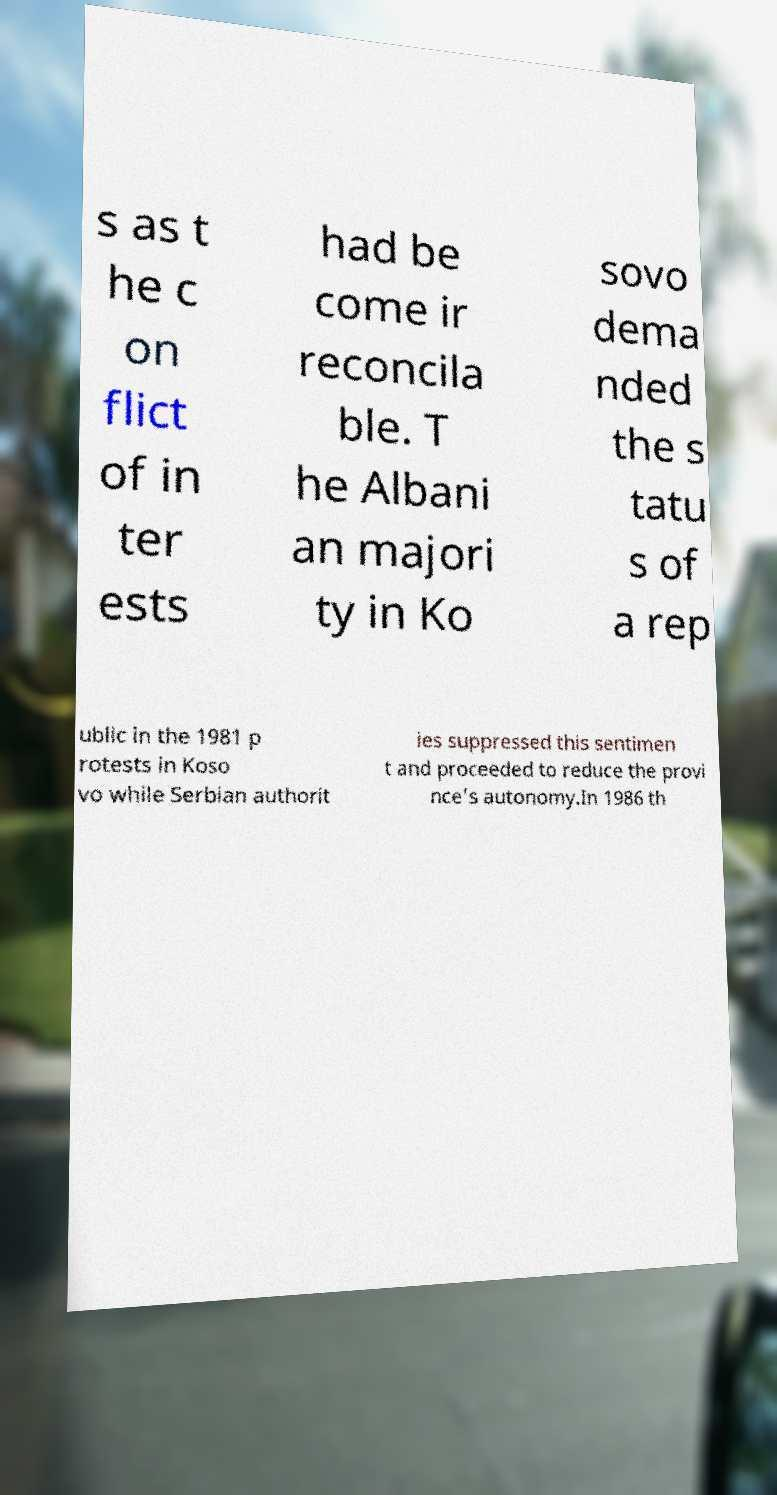For documentation purposes, I need the text within this image transcribed. Could you provide that? s as t he c on flict of in ter ests had be come ir reconcila ble. T he Albani an majori ty in Ko sovo dema nded the s tatu s of a rep ublic in the 1981 p rotests in Koso vo while Serbian authorit ies suppressed this sentimen t and proceeded to reduce the provi nce's autonomy.In 1986 th 